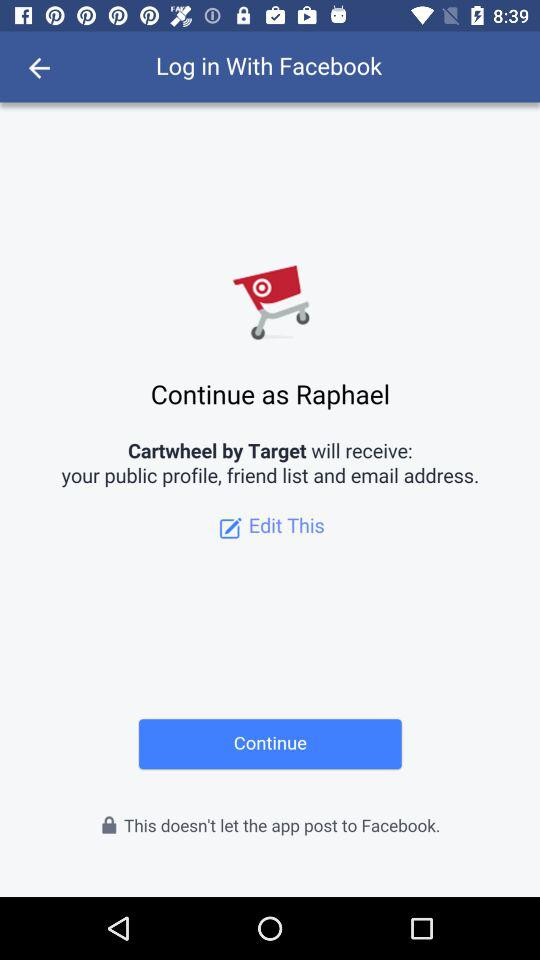What is the user name? The user name is Raphael. 